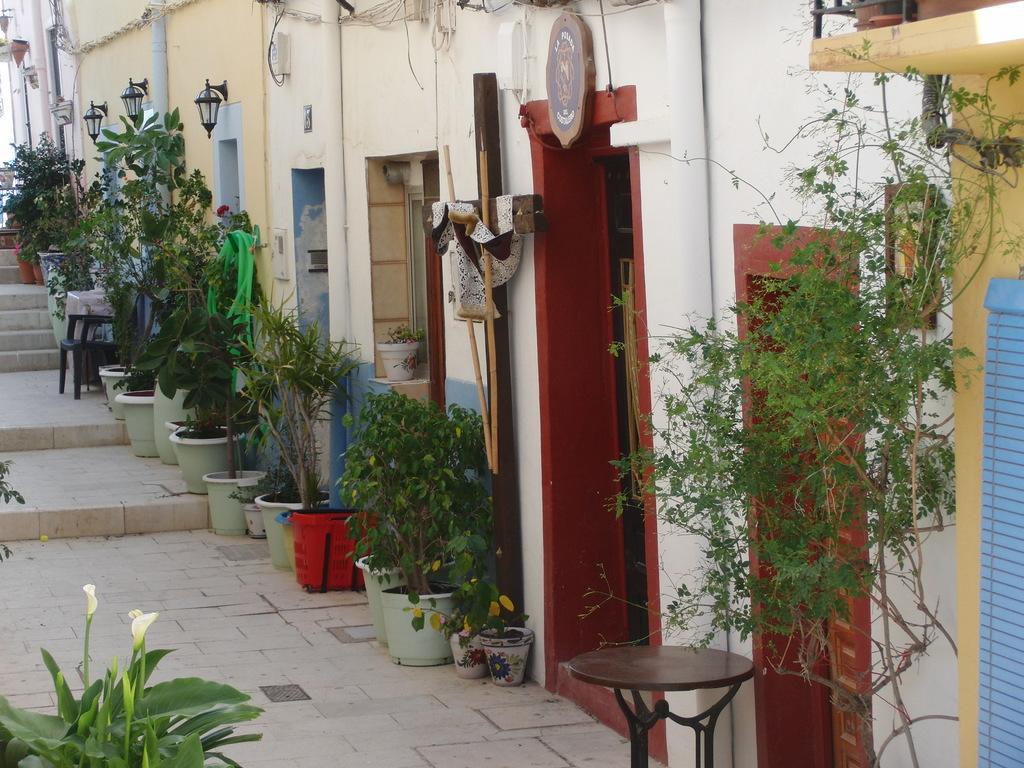Could you give a brief overview of what you see in this image? In this picture there are several flower pots kept in front of the doors. There are many small buildings with colorful doors. To the left side of the image there are small plants. 